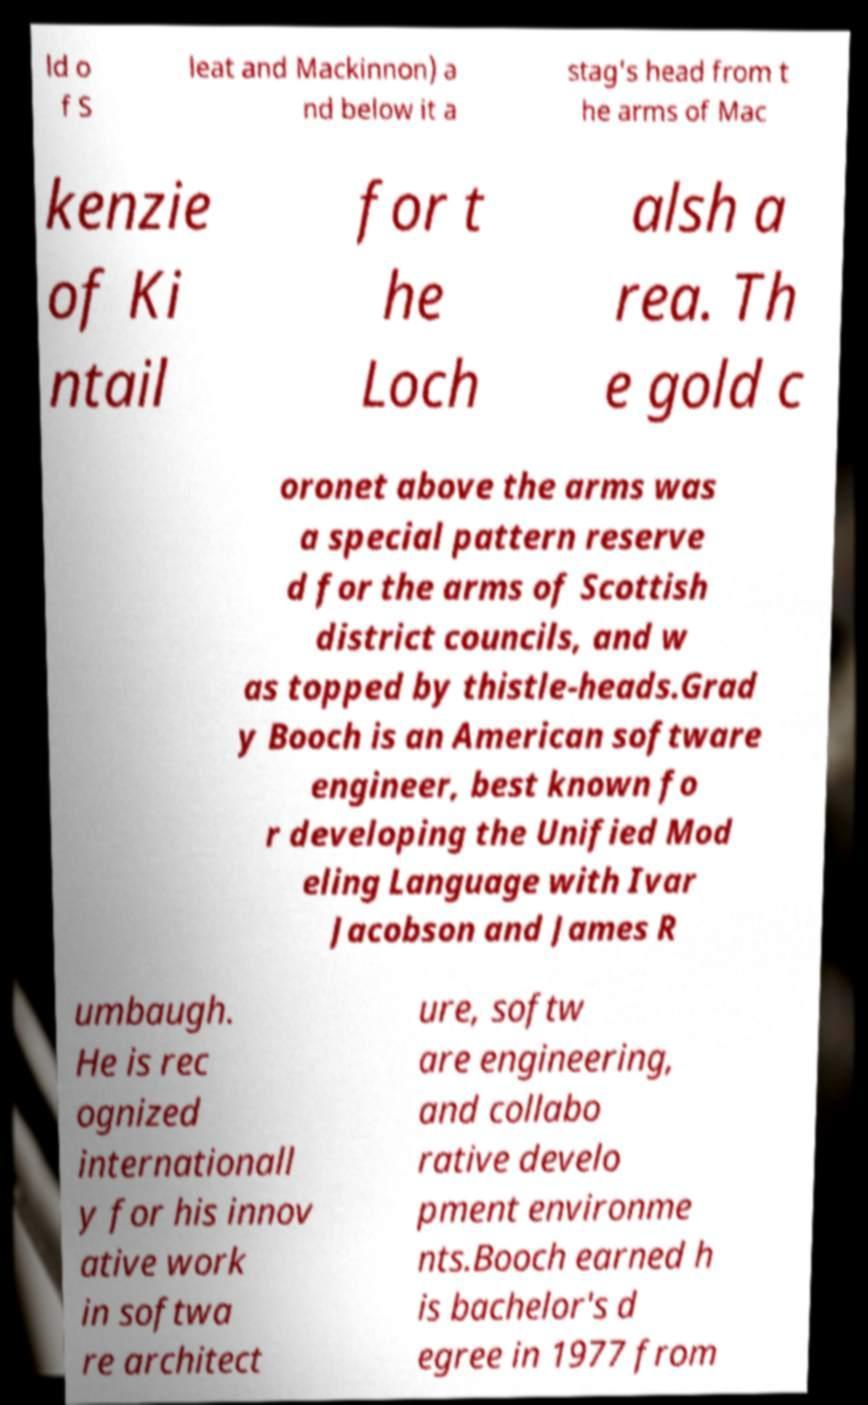Please identify and transcribe the text found in this image. ld o f S leat and Mackinnon) a nd below it a stag's head from t he arms of Mac kenzie of Ki ntail for t he Loch alsh a rea. Th e gold c oronet above the arms was a special pattern reserve d for the arms of Scottish district councils, and w as topped by thistle-heads.Grad y Booch is an American software engineer, best known fo r developing the Unified Mod eling Language with Ivar Jacobson and James R umbaugh. He is rec ognized internationall y for his innov ative work in softwa re architect ure, softw are engineering, and collabo rative develo pment environme nts.Booch earned h is bachelor's d egree in 1977 from 